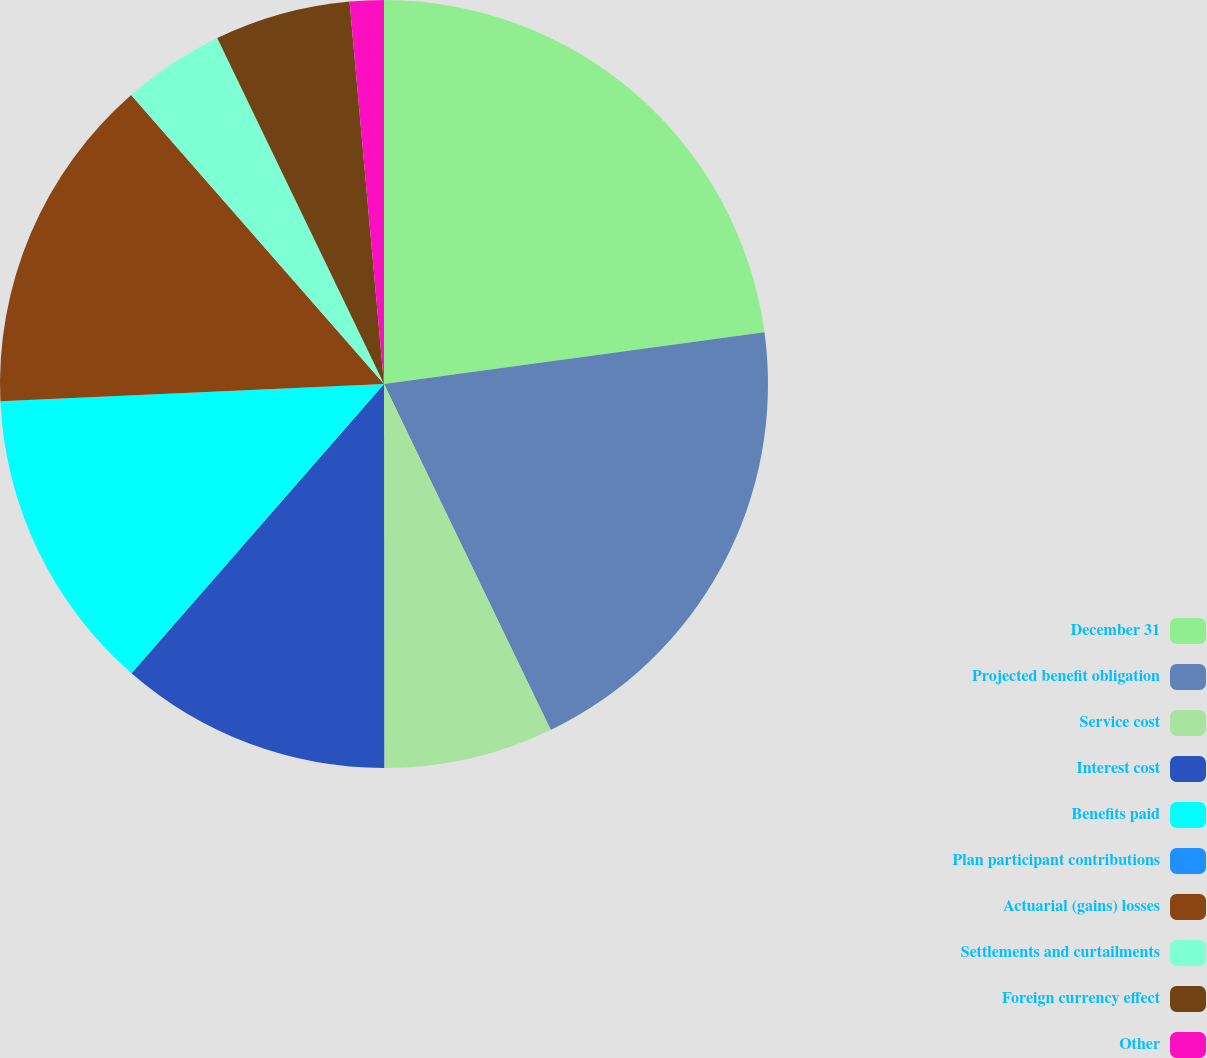Convert chart to OTSL. <chart><loc_0><loc_0><loc_500><loc_500><pie_chart><fcel>December 31<fcel>Projected benefit obligation<fcel>Service cost<fcel>Interest cost<fcel>Benefits paid<fcel>Plan participant contributions<fcel>Actuarial (gains) losses<fcel>Settlements and curtailments<fcel>Foreign currency effect<fcel>Other<nl><fcel>22.85%<fcel>20.0%<fcel>7.14%<fcel>11.43%<fcel>12.86%<fcel>0.0%<fcel>14.28%<fcel>4.29%<fcel>5.72%<fcel>1.43%<nl></chart> 